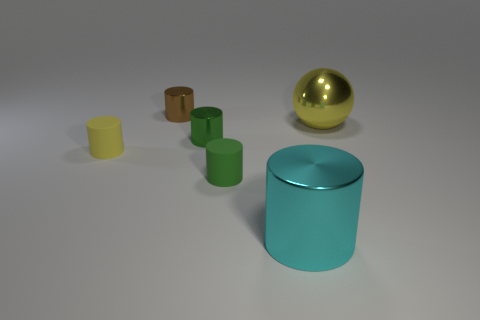What size is the thing that is the same color as the large ball?
Keep it short and to the point. Small. What is the color of the small cylinder that is on the left side of the tiny green metallic cylinder and to the right of the tiny yellow thing?
Keep it short and to the point. Brown. There is a yellow shiny thing that is in front of the small brown metal cylinder; what shape is it?
Your answer should be compact. Sphere. There is a cyan object that is made of the same material as the big sphere; what shape is it?
Give a very brief answer. Cylinder. What number of matte things are either big yellow things or cylinders?
Offer a very short reply. 2. How many metallic cylinders are behind the metallic thing that is in front of the yellow thing that is to the left of the large yellow thing?
Provide a succinct answer. 2. Do the shiny thing in front of the small yellow matte object and the yellow object that is right of the green matte thing have the same size?
Provide a short and direct response. Yes. There is a brown object that is the same shape as the big cyan object; what is its material?
Offer a very short reply. Metal. How many large objects are either brown shiny objects or green matte spheres?
Your answer should be compact. 0. What is the material of the brown object?
Your answer should be compact. Metal. 